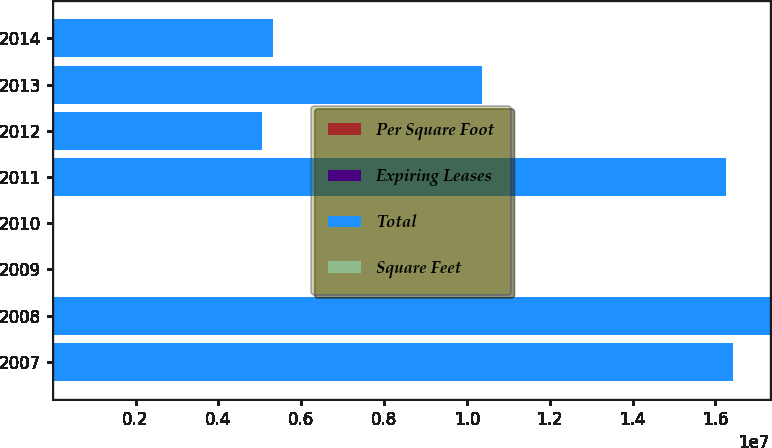<chart> <loc_0><loc_0><loc_500><loc_500><stacked_bar_chart><ecel><fcel>2007<fcel>2008<fcel>2009<fcel>2010<fcel>2011<fcel>2012<fcel>2013<fcel>2014<nl><fcel>Per Square Foot<fcel>204<fcel>225<fcel>289<fcel>163<fcel>112<fcel>32<fcel>59<fcel>29<nl><fcel>Expiring Leases<fcel>11<fcel>10.6<fcel>13.6<fcel>13<fcel>11.3<fcel>3.2<fcel>5.7<fcel>3.6<nl><fcel>Total<fcel>1.6432e+07<fcel>1.7314e+07<fcel>28.255<fcel>28.255<fcel>1.6267e+07<fcel>5.063e+06<fcel>1.0356e+07<fcel>5.309e+06<nl><fcel>Square Feet<fcel>25.01<fcel>27.3<fcel>25.87<fcel>27.51<fcel>24.05<fcel>26.56<fcel>30.34<fcel>24.79<nl></chart> 